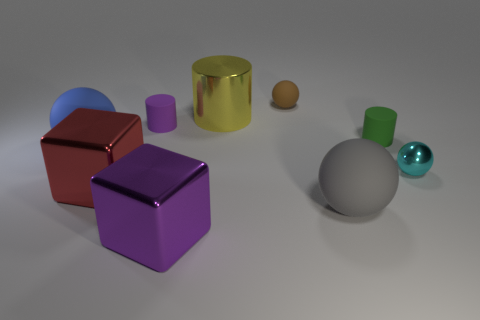Subtract all large gray balls. How many balls are left? 3 Subtract all gray balls. How many balls are left? 3 Add 1 tiny balls. How many objects exist? 10 Subtract all green balls. Subtract all red cylinders. How many balls are left? 4 Subtract all large yellow objects. Subtract all big green cylinders. How many objects are left? 8 Add 2 blue rubber balls. How many blue rubber balls are left? 3 Add 1 brown rubber objects. How many brown rubber objects exist? 2 Subtract 1 purple cylinders. How many objects are left? 8 Subtract all cylinders. How many objects are left? 6 